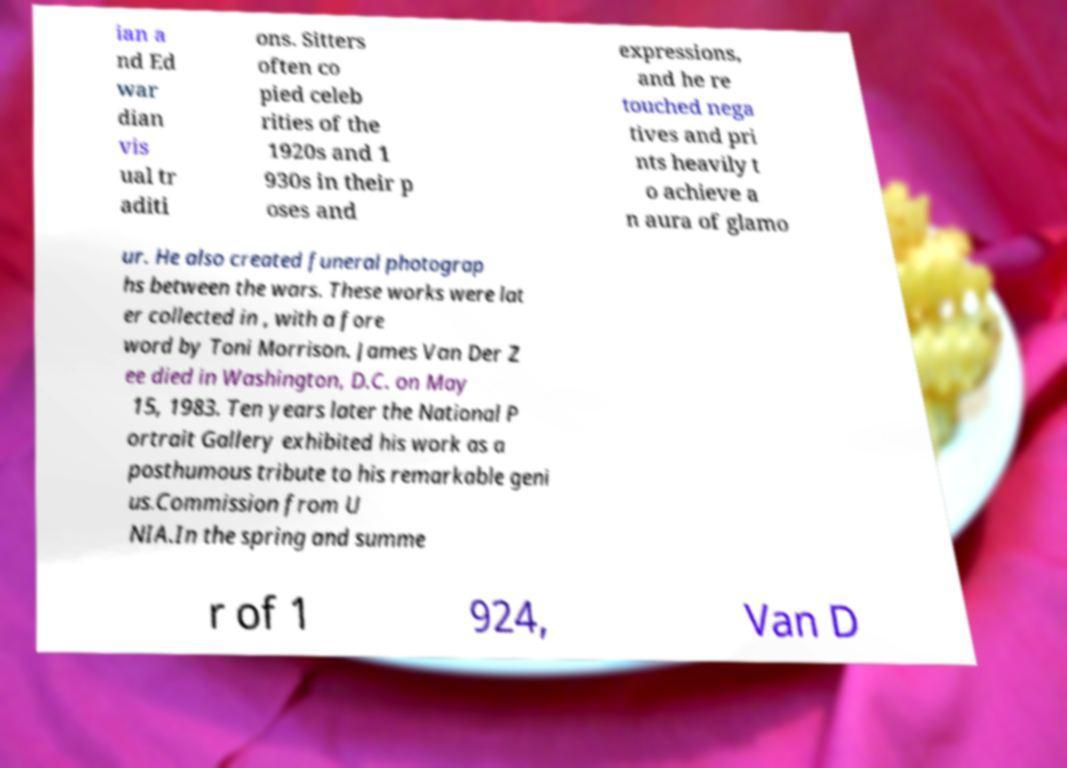Can you read and provide the text displayed in the image?This photo seems to have some interesting text. Can you extract and type it out for me? ian a nd Ed war dian vis ual tr aditi ons. Sitters often co pied celeb rities of the 1920s and 1 930s in their p oses and expressions, and he re touched nega tives and pri nts heavily t o achieve a n aura of glamo ur. He also created funeral photograp hs between the wars. These works were lat er collected in , with a fore word by Toni Morrison. James Van Der Z ee died in Washington, D.C. on May 15, 1983. Ten years later the National P ortrait Gallery exhibited his work as a posthumous tribute to his remarkable geni us.Commission from U NIA.In the spring and summe r of 1 924, Van D 